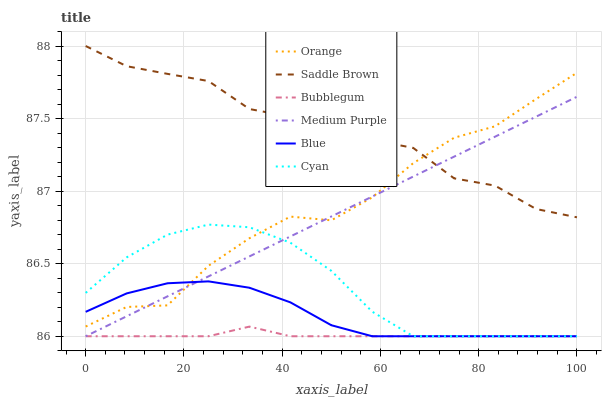Does Bubblegum have the minimum area under the curve?
Answer yes or no. Yes. Does Saddle Brown have the maximum area under the curve?
Answer yes or no. Yes. Does Medium Purple have the minimum area under the curve?
Answer yes or no. No. Does Medium Purple have the maximum area under the curve?
Answer yes or no. No. Is Medium Purple the smoothest?
Answer yes or no. Yes. Is Orange the roughest?
Answer yes or no. Yes. Is Bubblegum the smoothest?
Answer yes or no. No. Is Bubblegum the roughest?
Answer yes or no. No. Does Orange have the lowest value?
Answer yes or no. No. Does Medium Purple have the highest value?
Answer yes or no. No. Is Blue less than Saddle Brown?
Answer yes or no. Yes. Is Orange greater than Bubblegum?
Answer yes or no. Yes. Does Blue intersect Saddle Brown?
Answer yes or no. No. 